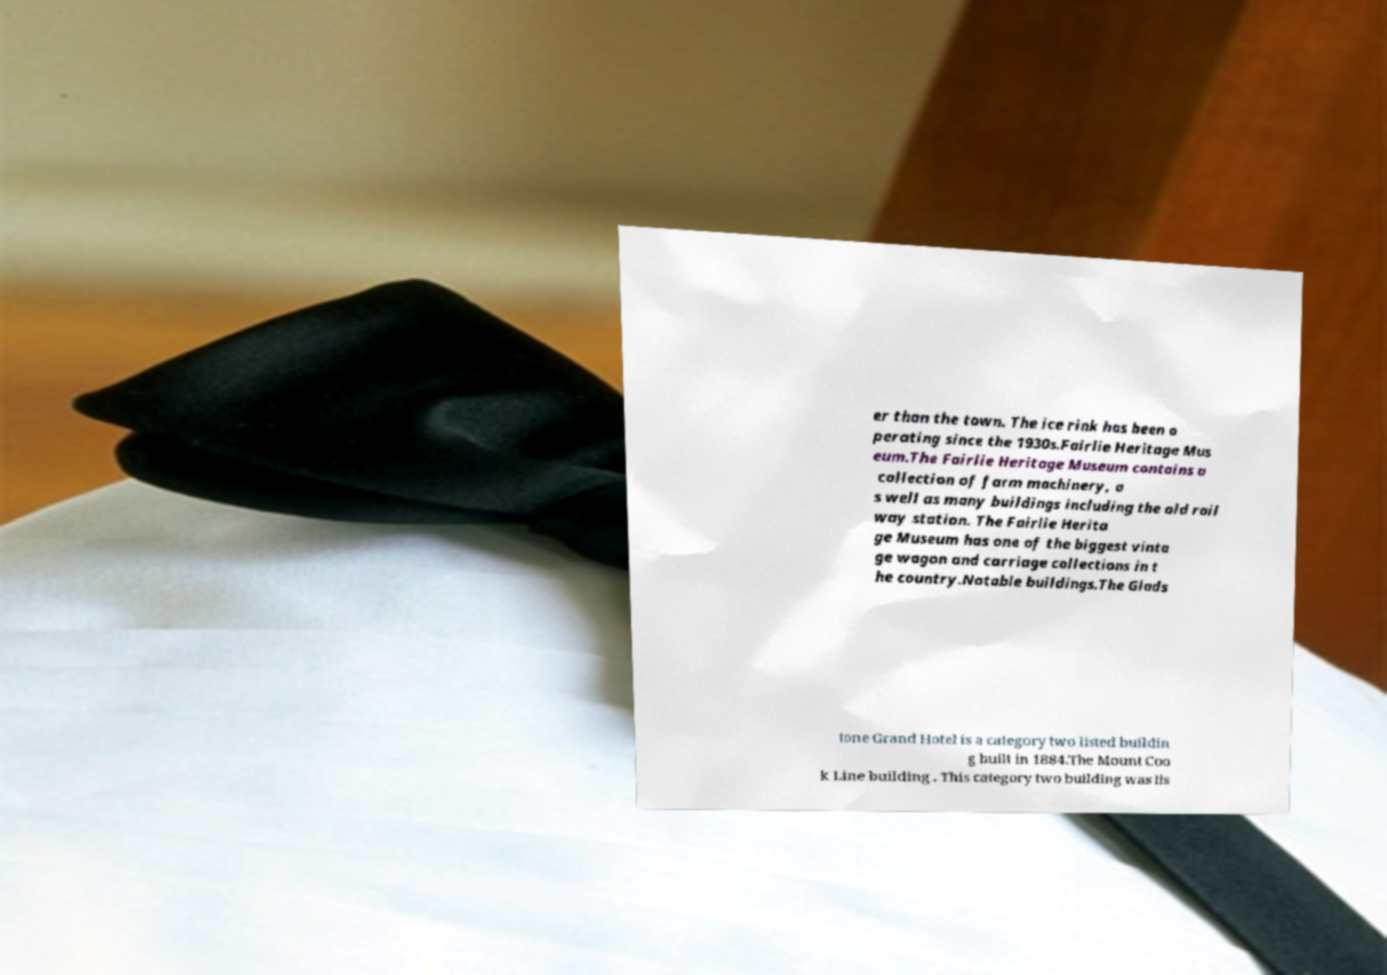There's text embedded in this image that I need extracted. Can you transcribe it verbatim? er than the town. The ice rink has been o perating since the 1930s.Fairlie Heritage Mus eum.The Fairlie Heritage Museum contains a collection of farm machinery, a s well as many buildings including the old rail way station. The Fairlie Herita ge Museum has one of the biggest vinta ge wagon and carriage collections in t he country.Notable buildings.The Glads tone Grand Hotel is a category two listed buildin g built in 1884.The Mount Coo k Line building . This category two building was lis 